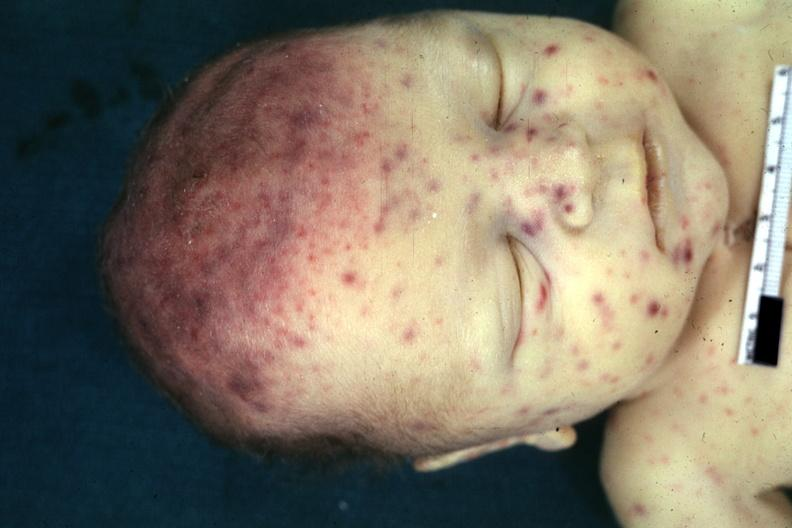how does this image show view of face?
Answer the question using a single word or phrase. With rash 